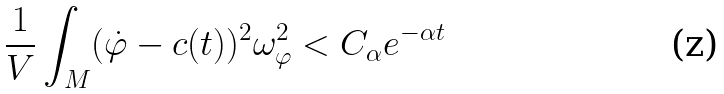<formula> <loc_0><loc_0><loc_500><loc_500>\frac { 1 } { V } \int _ { M } ( \dot { \varphi } - c ( t ) ) ^ { 2 } \omega _ { \varphi } ^ { 2 } < C _ { \alpha } e ^ { - \alpha t }</formula> 